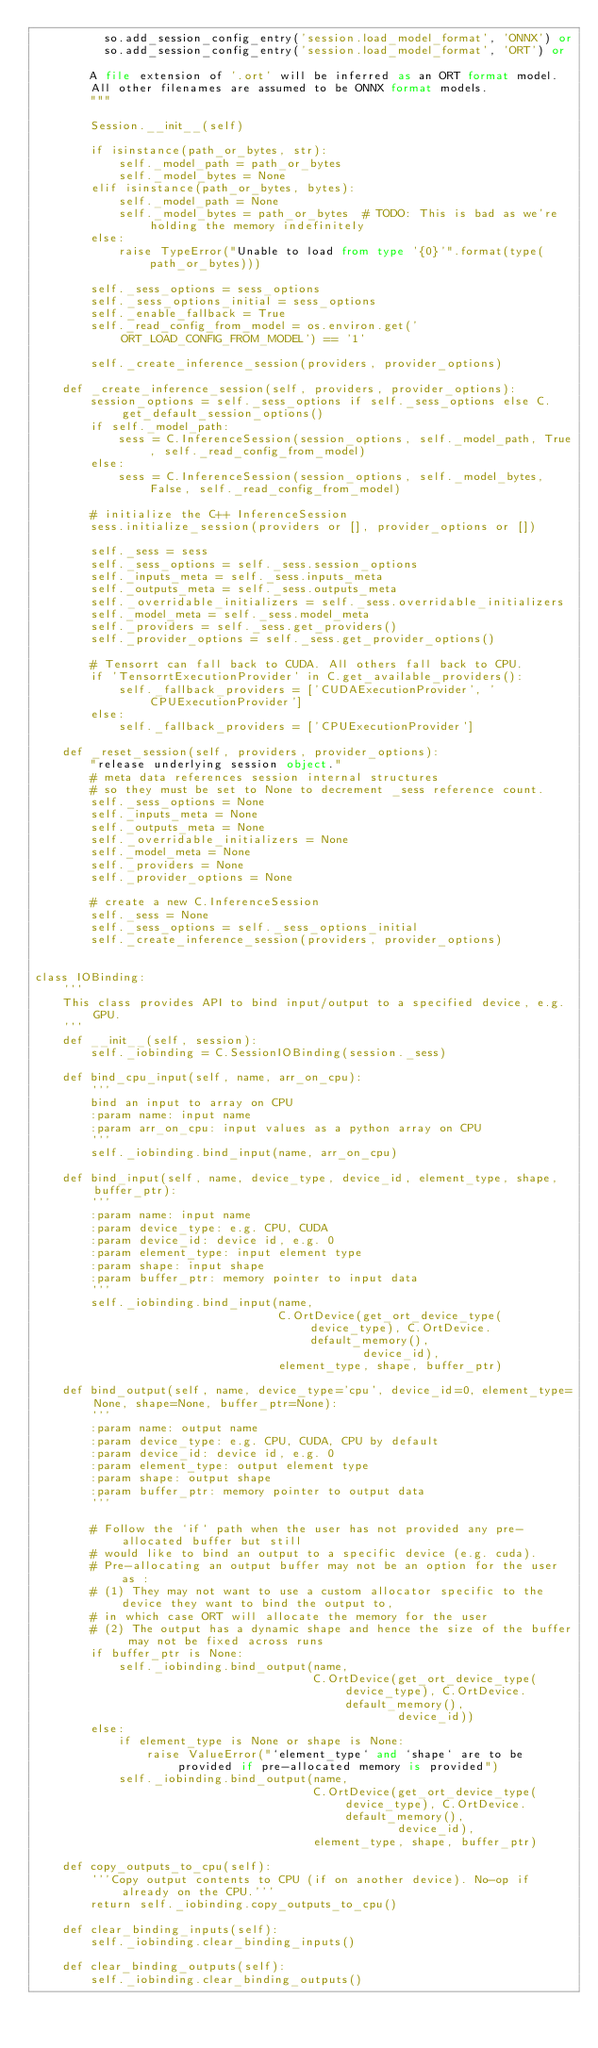Convert code to text. <code><loc_0><loc_0><loc_500><loc_500><_Python_>          so.add_session_config_entry('session.load_model_format', 'ONNX') or
          so.add_session_config_entry('session.load_model_format', 'ORT') or

        A file extension of '.ort' will be inferred as an ORT format model.
        All other filenames are assumed to be ONNX format models.
        """

        Session.__init__(self)

        if isinstance(path_or_bytes, str):
            self._model_path = path_or_bytes
            self._model_bytes = None
        elif isinstance(path_or_bytes, bytes):
            self._model_path = None
            self._model_bytes = path_or_bytes  # TODO: This is bad as we're holding the memory indefinitely
        else:
            raise TypeError("Unable to load from type '{0}'".format(type(path_or_bytes)))

        self._sess_options = sess_options
        self._sess_options_initial = sess_options
        self._enable_fallback = True
        self._read_config_from_model = os.environ.get('ORT_LOAD_CONFIG_FROM_MODEL') == '1'

        self._create_inference_session(providers, provider_options)

    def _create_inference_session(self, providers, provider_options):
        session_options = self._sess_options if self._sess_options else C.get_default_session_options()
        if self._model_path:
            sess = C.InferenceSession(session_options, self._model_path, True, self._read_config_from_model)
        else:
            sess = C.InferenceSession(session_options, self._model_bytes, False, self._read_config_from_model)

        # initialize the C++ InferenceSession
        sess.initialize_session(providers or [], provider_options or [])

        self._sess = sess
        self._sess_options = self._sess.session_options
        self._inputs_meta = self._sess.inputs_meta
        self._outputs_meta = self._sess.outputs_meta
        self._overridable_initializers = self._sess.overridable_initializers
        self._model_meta = self._sess.model_meta
        self._providers = self._sess.get_providers()
        self._provider_options = self._sess.get_provider_options()

        # Tensorrt can fall back to CUDA. All others fall back to CPU.
        if 'TensorrtExecutionProvider' in C.get_available_providers():
            self._fallback_providers = ['CUDAExecutionProvider', 'CPUExecutionProvider']
        else:
            self._fallback_providers = ['CPUExecutionProvider']

    def _reset_session(self, providers, provider_options):
        "release underlying session object."
        # meta data references session internal structures
        # so they must be set to None to decrement _sess reference count.
        self._sess_options = None
        self._inputs_meta = None
        self._outputs_meta = None
        self._overridable_initializers = None
        self._model_meta = None
        self._providers = None
        self._provider_options = None

        # create a new C.InferenceSession
        self._sess = None
        self._sess_options = self._sess_options_initial
        self._create_inference_session(providers, provider_options)


class IOBinding:
    '''
    This class provides API to bind input/output to a specified device, e.g. GPU.
    '''
    def __init__(self, session):
        self._iobinding = C.SessionIOBinding(session._sess)

    def bind_cpu_input(self, name, arr_on_cpu):
        '''
        bind an input to array on CPU
        :param name: input name
        :param arr_on_cpu: input values as a python array on CPU
        '''
        self._iobinding.bind_input(name, arr_on_cpu)

    def bind_input(self, name, device_type, device_id, element_type, shape, buffer_ptr):
        '''
        :param name: input name
        :param device_type: e.g. CPU, CUDA
        :param device_id: device id, e.g. 0
        :param element_type: input element type
        :param shape: input shape
        :param buffer_ptr: memory pointer to input data
        '''
        self._iobinding.bind_input(name,
                                   C.OrtDevice(get_ort_device_type(device_type), C.OrtDevice.default_memory(),
                                               device_id),
                                   element_type, shape, buffer_ptr)

    def bind_output(self, name, device_type='cpu', device_id=0, element_type=None, shape=None, buffer_ptr=None):
        '''
        :param name: output name
        :param device_type: e.g. CPU, CUDA, CPU by default
        :param device_id: device id, e.g. 0
        :param element_type: output element type
        :param shape: output shape
        :param buffer_ptr: memory pointer to output data
        '''

        # Follow the `if` path when the user has not provided any pre-allocated buffer but still
        # would like to bind an output to a specific device (e.g. cuda).
        # Pre-allocating an output buffer may not be an option for the user as :
        # (1) They may not want to use a custom allocator specific to the device they want to bind the output to,
        # in which case ORT will allocate the memory for the user
        # (2) The output has a dynamic shape and hence the size of the buffer may not be fixed across runs
        if buffer_ptr is None:
            self._iobinding.bind_output(name,
                                        C.OrtDevice(get_ort_device_type(device_type), C.OrtDevice.default_memory(),
                                                    device_id))
        else:
            if element_type is None or shape is None:
                raise ValueError("`element_type` and `shape` are to be provided if pre-allocated memory is provided")
            self._iobinding.bind_output(name,
                                        C.OrtDevice(get_ort_device_type(device_type), C.OrtDevice.default_memory(),
                                                    device_id),
                                        element_type, shape, buffer_ptr)

    def copy_outputs_to_cpu(self):
        '''Copy output contents to CPU (if on another device). No-op if already on the CPU.'''
        return self._iobinding.copy_outputs_to_cpu()

    def clear_binding_inputs(self):
        self._iobinding.clear_binding_inputs()

    def clear_binding_outputs(self):
        self._iobinding.clear_binding_outputs()
</code> 